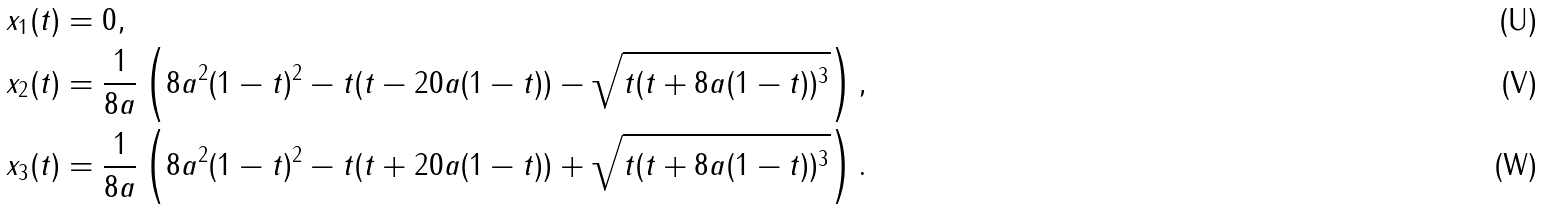Convert formula to latex. <formula><loc_0><loc_0><loc_500><loc_500>x _ { 1 } ( t ) & = 0 , \\ x _ { 2 } ( t ) & = \frac { 1 } { 8 a } \left ( 8 a ^ { 2 } ( 1 - t ) ^ { 2 } - t ( t - 2 0 a ( 1 - t ) ) - \sqrt { t ( t + 8 a ( 1 - t ) ) ^ { 3 } } \right ) , \\ x _ { 3 } ( t ) & = \frac { 1 } { 8 a } \left ( 8 a ^ { 2 } ( 1 - t ) ^ { 2 } - t ( t + 2 0 a ( 1 - t ) ) + \sqrt { t ( t + 8 a ( 1 - t ) ) ^ { 3 } } \right ) .</formula> 